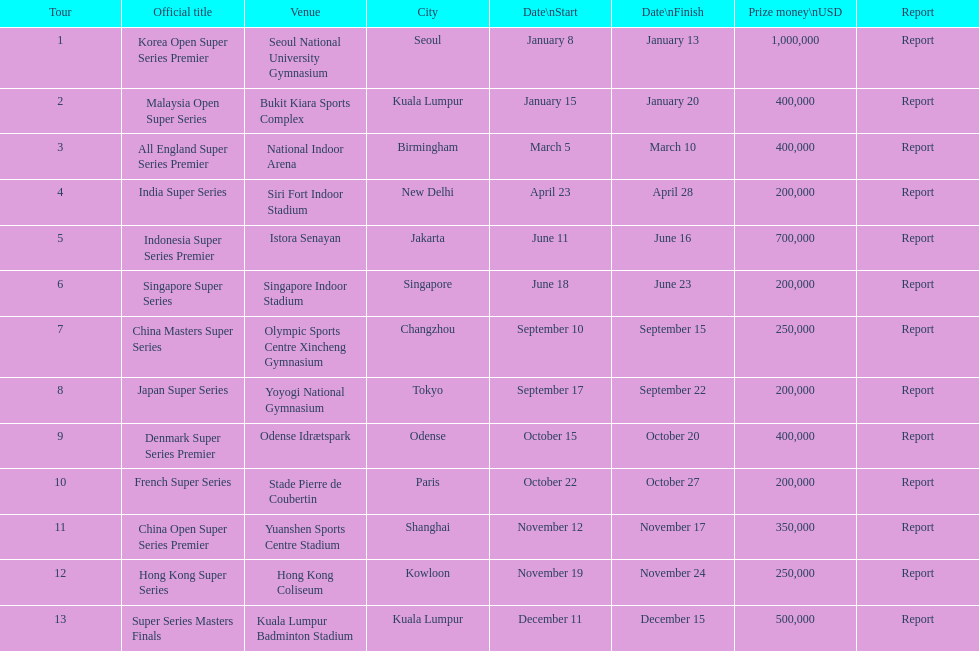Does the malaysia open super series pay more or less than french super series? More. 